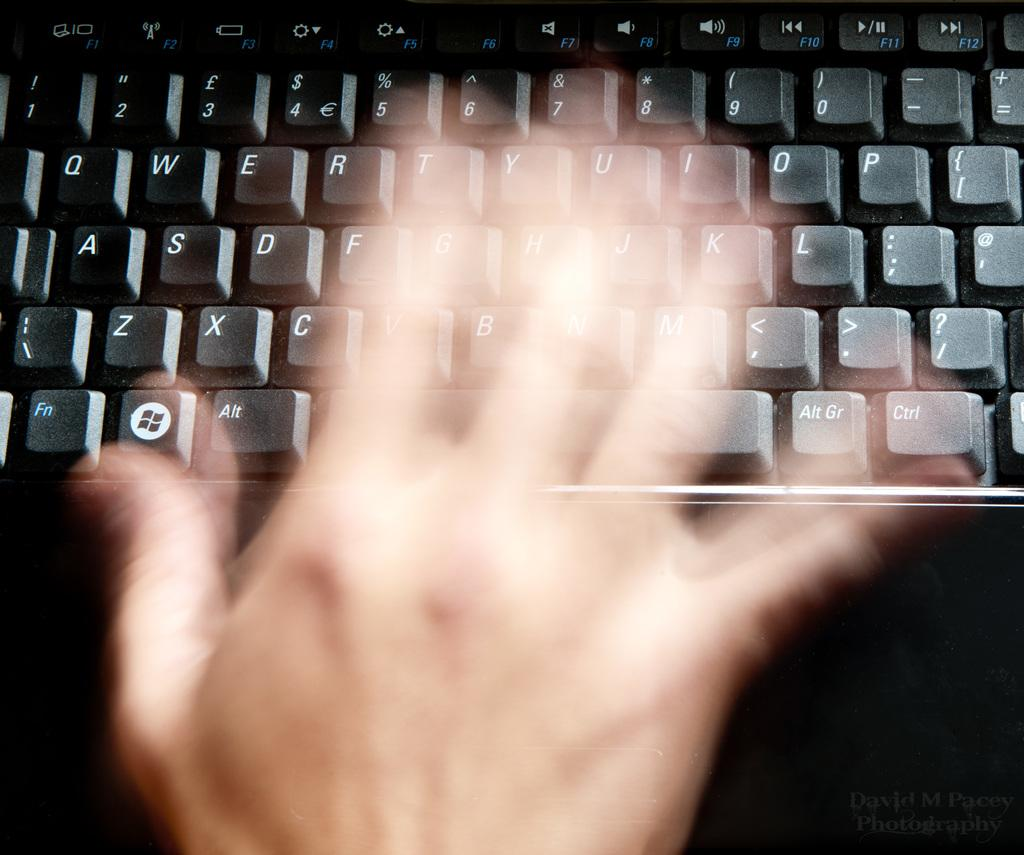Provide a one-sentence caption for the provided image. A computer keyboard with the function key visible at the bottom left. 